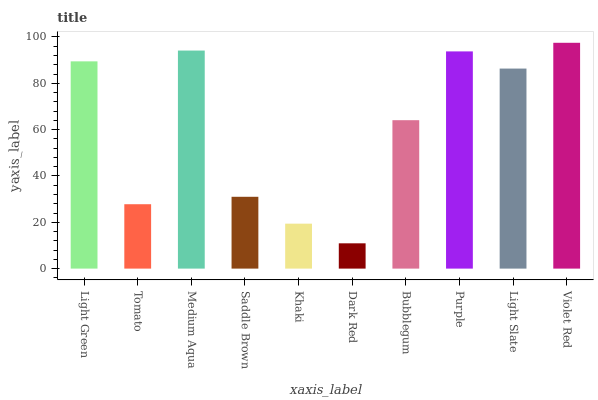Is Dark Red the minimum?
Answer yes or no. Yes. Is Violet Red the maximum?
Answer yes or no. Yes. Is Tomato the minimum?
Answer yes or no. No. Is Tomato the maximum?
Answer yes or no. No. Is Light Green greater than Tomato?
Answer yes or no. Yes. Is Tomato less than Light Green?
Answer yes or no. Yes. Is Tomato greater than Light Green?
Answer yes or no. No. Is Light Green less than Tomato?
Answer yes or no. No. Is Light Slate the high median?
Answer yes or no. Yes. Is Bubblegum the low median?
Answer yes or no. Yes. Is Bubblegum the high median?
Answer yes or no. No. Is Violet Red the low median?
Answer yes or no. No. 